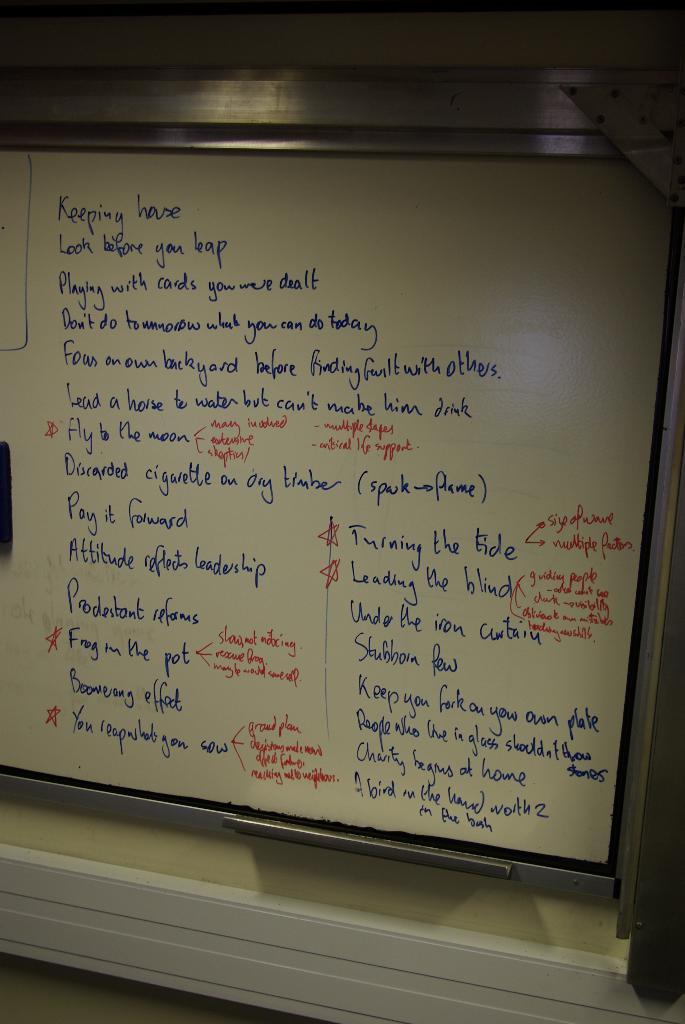Provide a one-sentence caption for the provided image. A whiteboard has a list of rules including "Look before you leap" and "Pay it forward" written on it. 